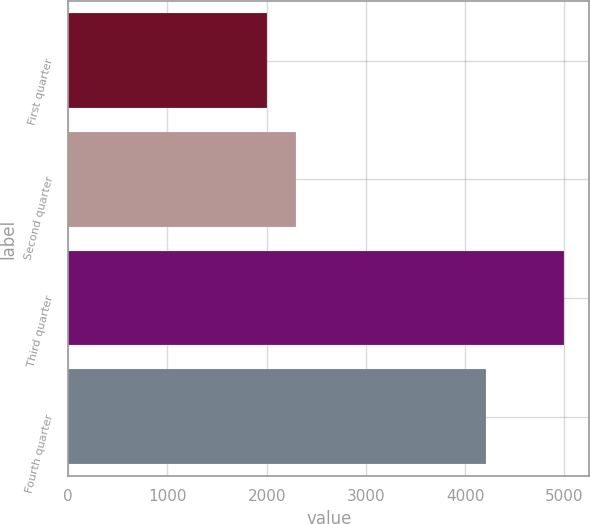Convert chart. <chart><loc_0><loc_0><loc_500><loc_500><bar_chart><fcel>First quarter<fcel>Second quarter<fcel>Third quarter<fcel>Fourth quarter<nl><fcel>2000<fcel>2300<fcel>5000<fcel>4209<nl></chart> 